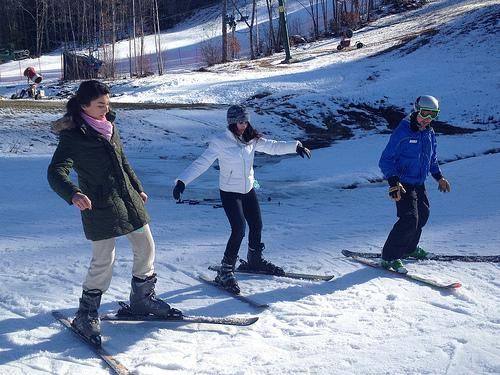Question: where is the picture taken?
Choices:
A. In an operating room.
B. Ski slope.
C. In the space station.
D. Down a well.
Answer with the letter. Answer: B Question: what are the people wearing on their feet?
Choices:
A. Boots.
B. Skis.
C. Sandals.
D. Flippers.
Answer with the letter. Answer: B Question: what is on the ground?
Choices:
A. Snow.
B. Grass.
C. Ice.
D. Gravel.
Answer with the letter. Answer: A Question: what is on the head of the man in blue?
Choices:
A. Baseball cap.
B. Ski hat.
C. Helmet.
D. Goggles.
Answer with the letter. Answer: C Question: what does the woman in the white coat have on her hands?
Choices:
A. Rings.
B. Long fingernails.
C. Gloves.
D. Mittens.
Answer with the letter. Answer: C 